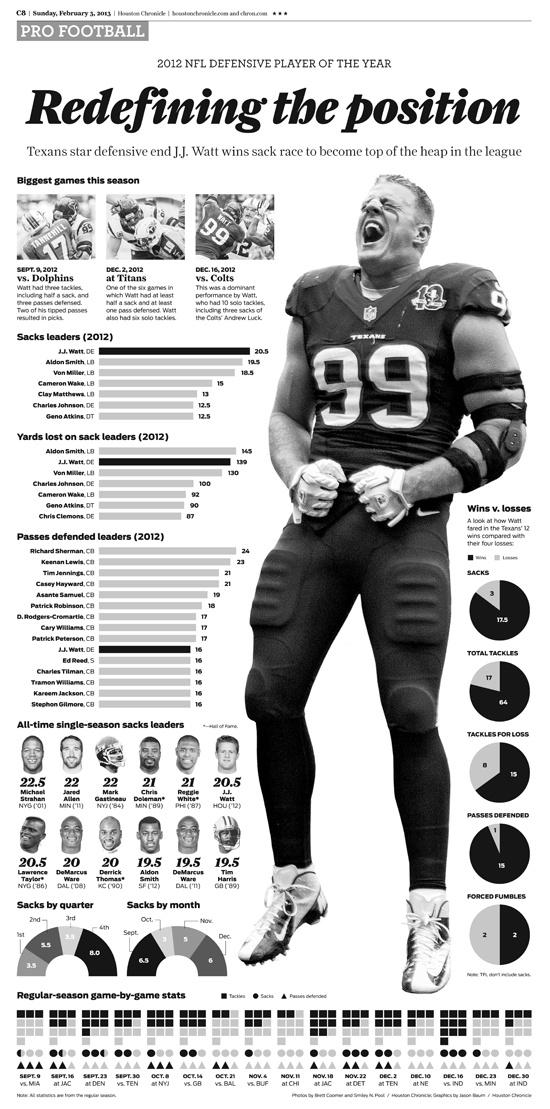Mention a couple of crucial points in this snapshot. Keenan Lewis has defended the second highest number of passes in 2012. Matt played a football match against the Colts team on December 16, 2012. There were a total of 5 tackles in the game that took place on September 16 at JAC. Detroit's November 22 game featured 2 passes that were successfully defended. Matt has won 17.5% of his sacks. 